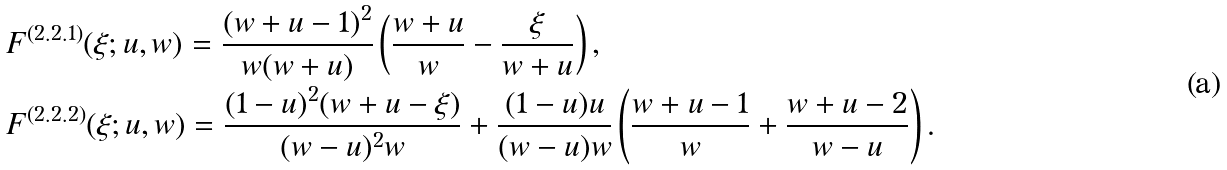Convert formula to latex. <formula><loc_0><loc_0><loc_500><loc_500>& F ^ { ( 2 . 2 . 1 ) } ( \xi ; u , w ) = \frac { ( w + u - 1 ) ^ { 2 } } { w ( w + u ) } \left ( \frac { w + u } { w } - \frac { \xi } { w + u } \right ) , \\ & F ^ { ( 2 . 2 . 2 ) } ( \xi ; u , w ) = \frac { ( 1 - u ) ^ { 2 } ( w + u - \xi ) } { ( w - u ) ^ { 2 } w } + \frac { ( 1 - u ) u } { ( w - u ) w } \left ( \frac { w + u - 1 } { w } + \frac { w + u - 2 } { w - u } \right ) .</formula> 